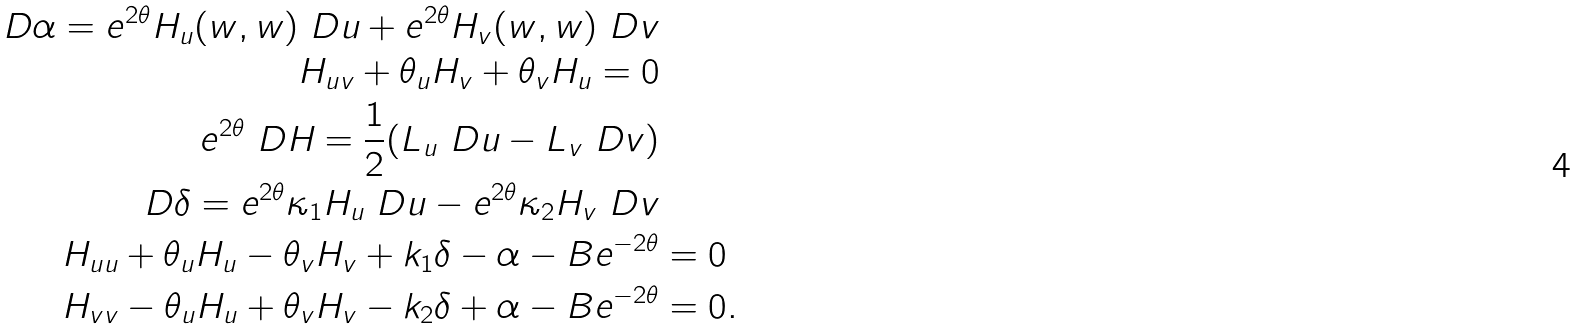<formula> <loc_0><loc_0><loc_500><loc_500>\ D \alpha = e ^ { 2 \theta } H _ { u } ( w , w ) \ D u + e ^ { 2 \theta } H _ { v } ( w , w ) \ D v \\ H _ { u v } + \theta _ { u } H _ { v } + \theta _ { v } H _ { u } = 0 \\ e ^ { 2 \theta } \ D H = \frac { 1 } { 2 } ( L _ { u } \ D u - L _ { v } \ D v ) \\ \ D \delta = e ^ { 2 \theta } \kappa _ { 1 } H _ { u } \ D u - e ^ { 2 \theta } \kappa _ { 2 } H _ { v } \ D v \\ H _ { u u } + \theta _ { u } H _ { u } - \theta _ { v } H _ { v } + k _ { 1 } \delta - \alpha - B e ^ { - 2 \theta } & = 0 \\ H _ { v v } - \theta _ { u } H _ { u } + \theta _ { v } H _ { v } - k _ { 2 } \delta + \alpha - B e ^ { - 2 \theta } & = 0 .</formula> 